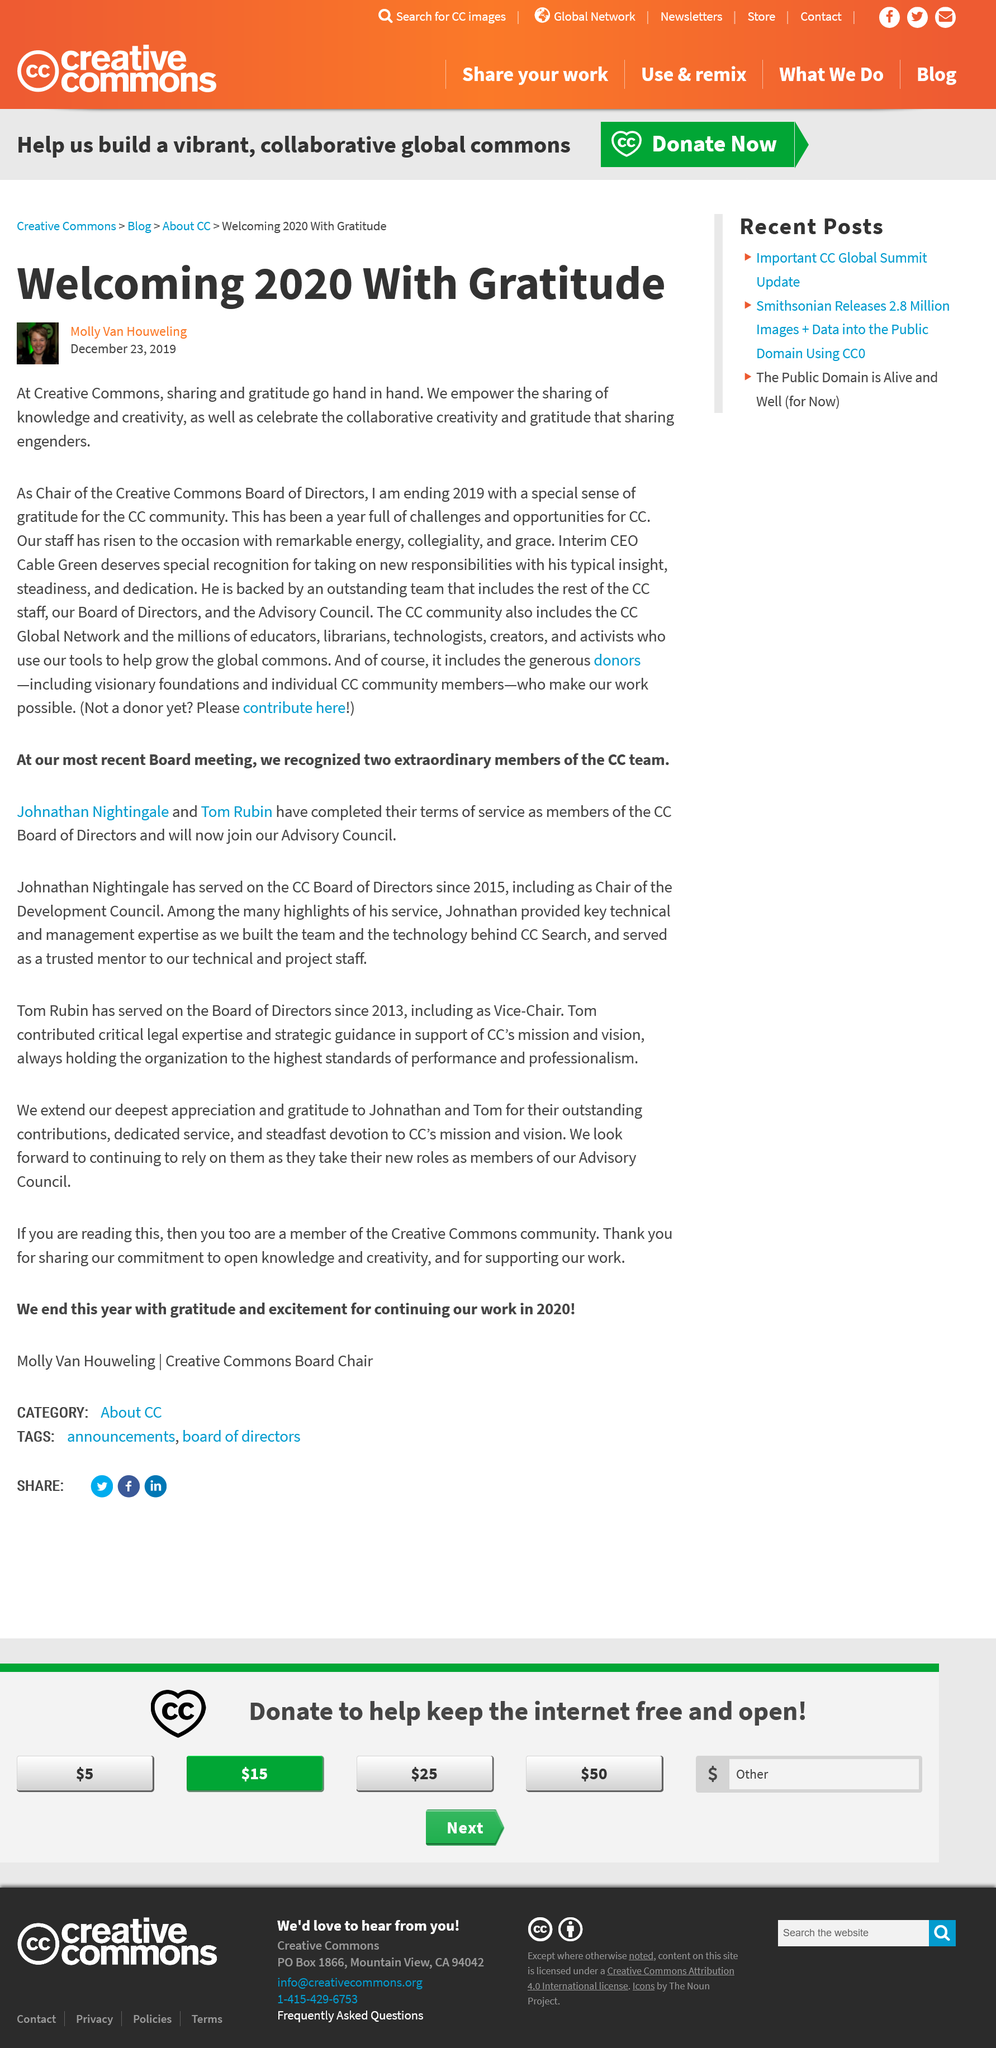Draw attention to some important aspects in this diagram. Yes, the Community of Donors (CC) includes the donors. As of now, the interim CEO of CC is Cable Green. I, [name], believe that creative commons and gratitude go hand in hand when it comes to sharing. 